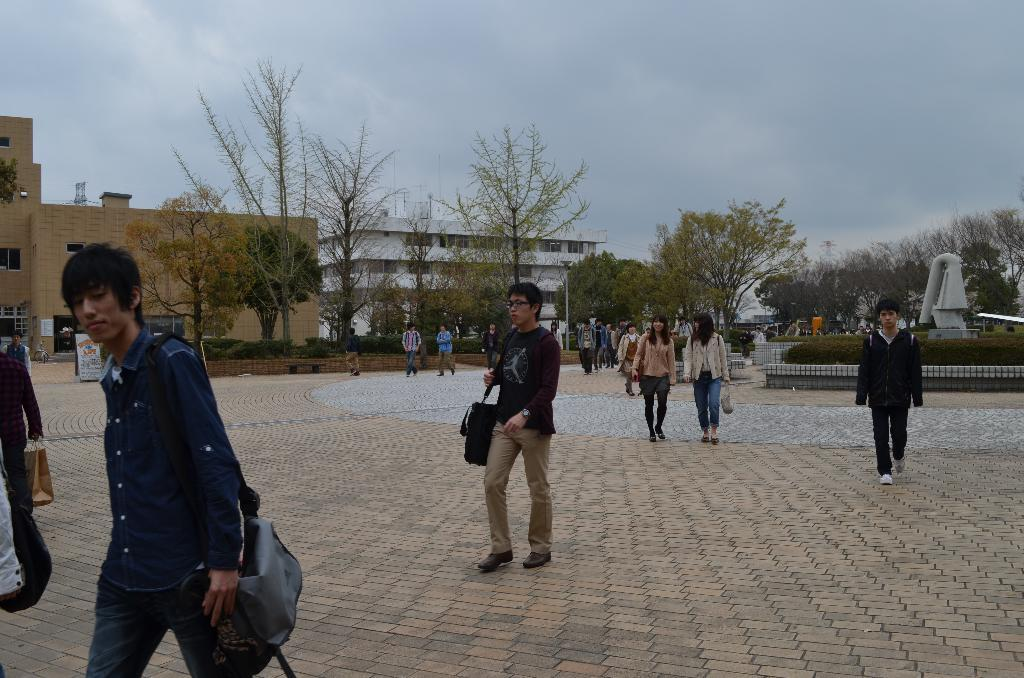What are the people in the foreground of the image doing? The persons in the foreground of the image are walking on the path. What can be seen in the background of the image? In the background of the image, there is a garden, trees, buildings, and the sky. How many celestial bodies are visible in the sky? One celestial body, a cloud, is visible in the sky. What type of shirt is the pest wearing in the image? There is no pest present in the image, and therefore no shirt can be associated with it. 